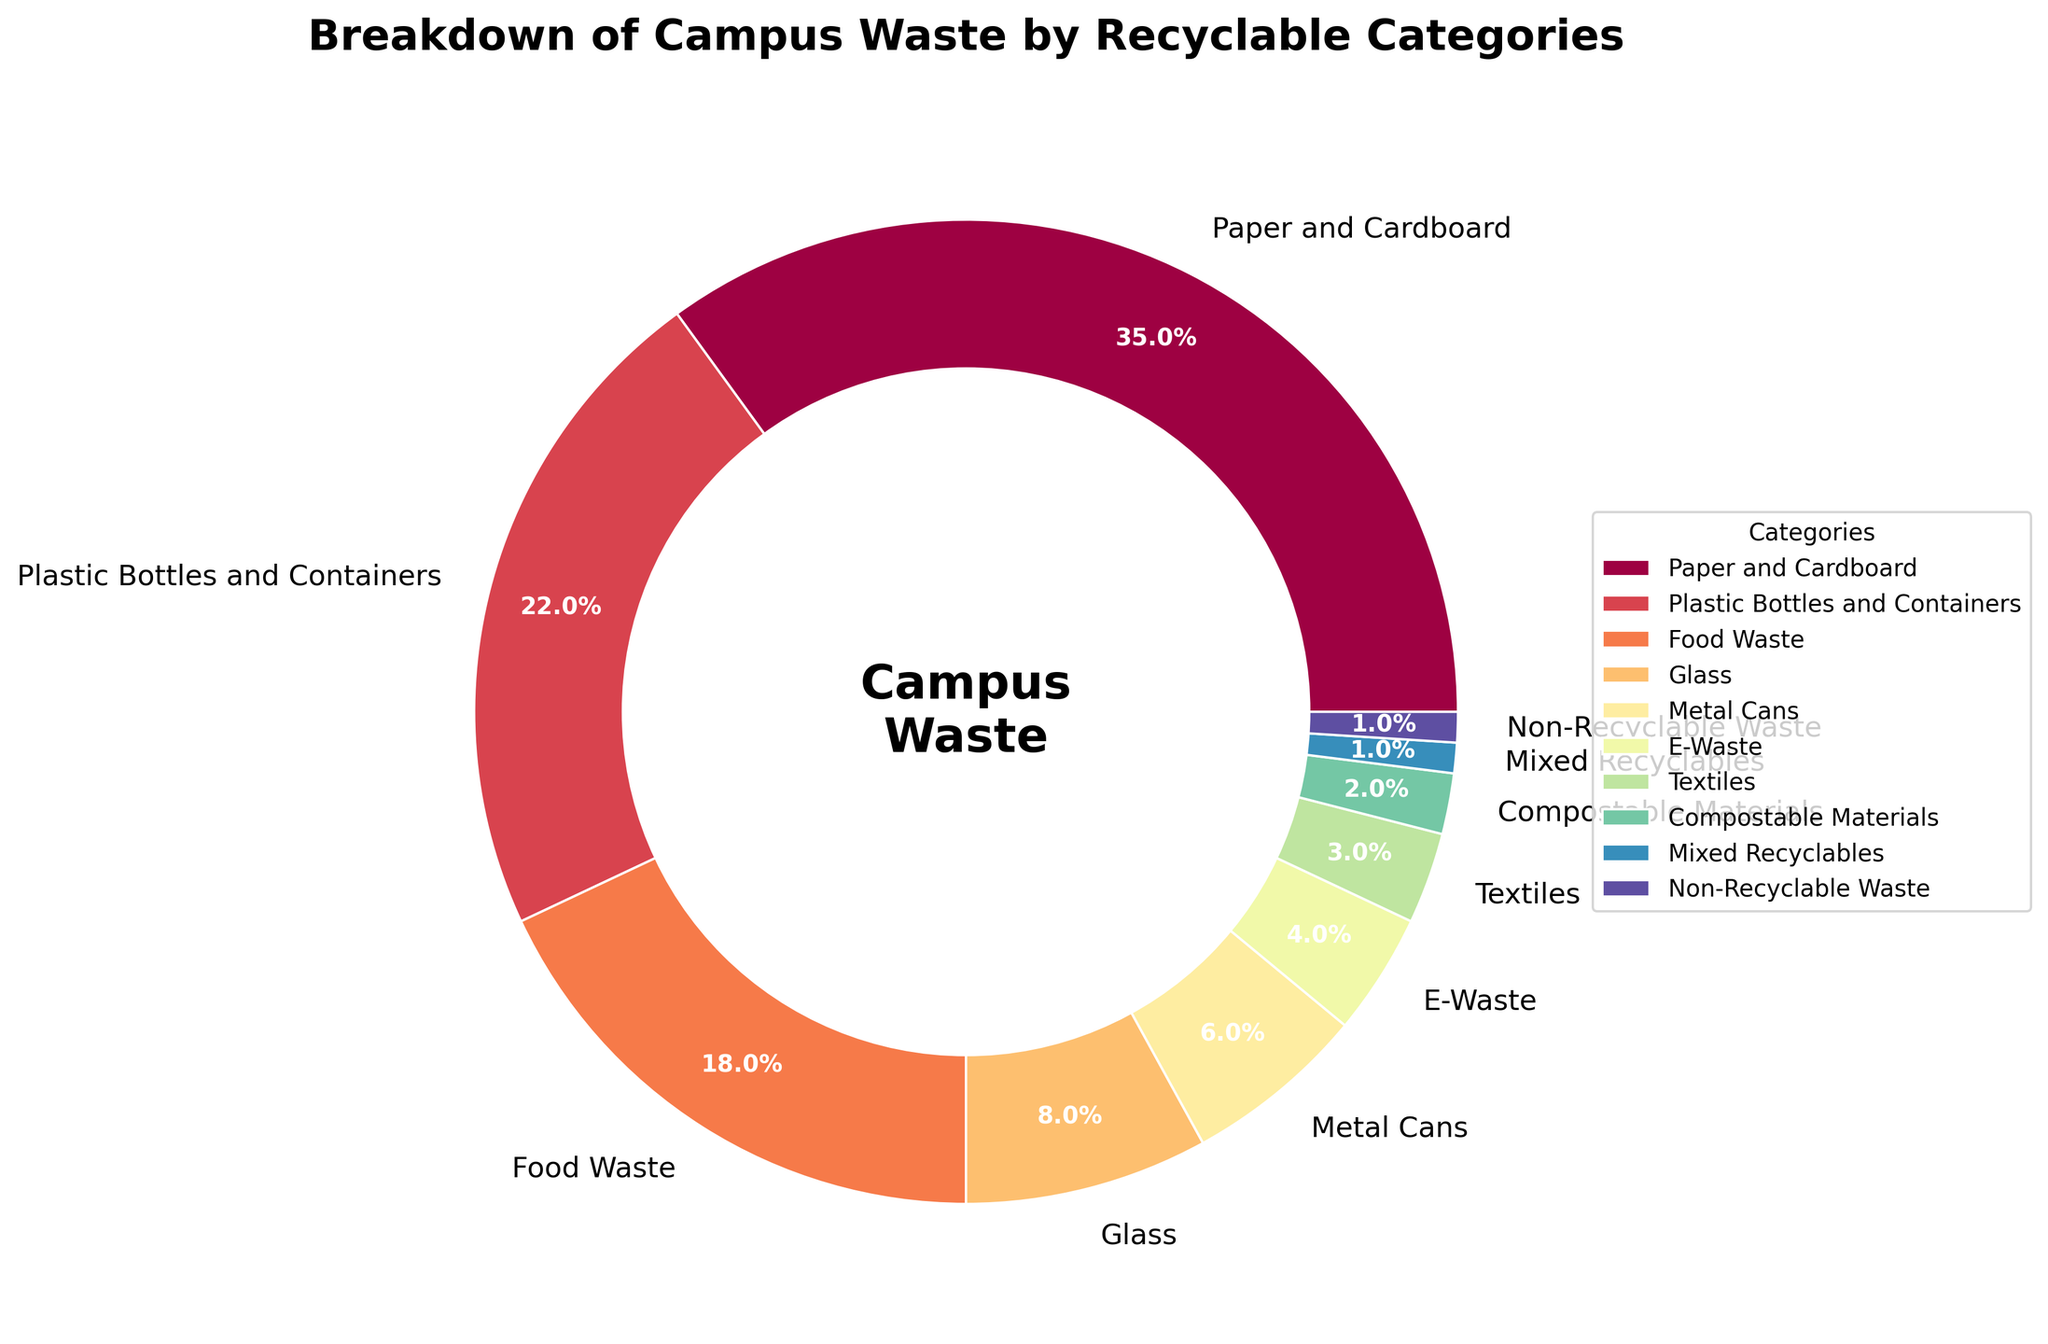Which category occupies the largest portion of the pie chart? The largest portion in the pie chart is identified by the segment with the highest percentage. By examining the chart or the data, "Paper and Cardboard" has the highest percentage at 35%.
Answer: Paper and Cardboard What is the combined percentage of Food Waste and Plastic Bottles and Containers? To find the combined percentage, we add the percentages of the two categories: Food Waste (18%) and Plastic Bottles and Containers (22%). Thus, 18% + 22% = 40%.
Answer: 40% Which categories each have a percentage smaller than Metal Cans? Categories with a smaller percentage than "Metal Cans" (6%) include E-Waste, Textiles, Compostable Materials, Mixed Recyclables, and Non-Recyclable Waste.
Answer: E-Waste, Textiles, Compostable Materials, Mixed Recyclables, and Non-Recyclable Waste How many categories have a percentage of 5% or more? By scanning the pie chart, count the number of categories with a percentage value of 5% or higher. These are: Paper and Cardboard (35%), Plastic Bottles and Containers (22%), Food Waste (18%), Glass (8%), and Metal Cans (6%). This results in 5 categories.
Answer: 5 What is the difference in percentage between the highest and lowest categories? To find the difference, subtract the percentage of the category with the lowest percentage (Non-Recyclable Waste, 1%) from the category with the highest percentage (Paper and Cardboard, 35%): 35% - 1% = 34%.
Answer: 34% Is the percentage of E-Waste greater than the percentage of Textiles? The percentage of E-Waste is 4%, and the percentage of Textiles is 3%. Checking their values confirms that 4% is greater than 3%.
Answer: Yes What is the total percentage of all categories except Paper and Cardboard and Plastic Bottles and Containers? To find this, subtract the combined percentage of Paper and Cardboard and Plastic Bottles and Containers from 100%: 100% - (35% + 22%) = 100% - 57% = 43%.
Answer: 43% Which category is represented by the darkest color on the pie chart? According to the chromatic gradient, the darkest color often corresponds to the smallest segment. In the pie chart, this belongs to either Mixed Recyclables or Non-Recyclable Waste, both at 1%.
Answer: Mixed Recyclables or Non-Recyclable Waste 